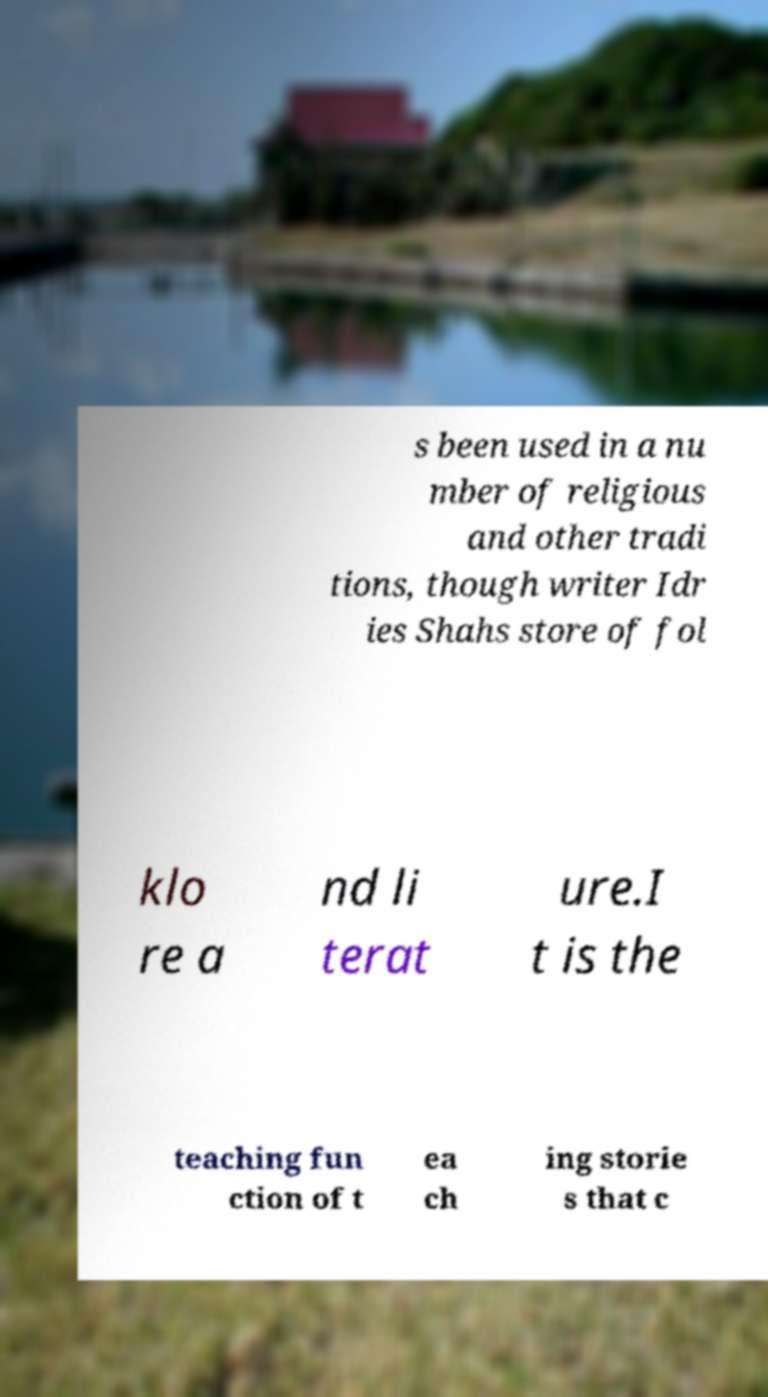Could you assist in decoding the text presented in this image and type it out clearly? s been used in a nu mber of religious and other tradi tions, though writer Idr ies Shahs store of fol klo re a nd li terat ure.I t is the teaching fun ction of t ea ch ing storie s that c 